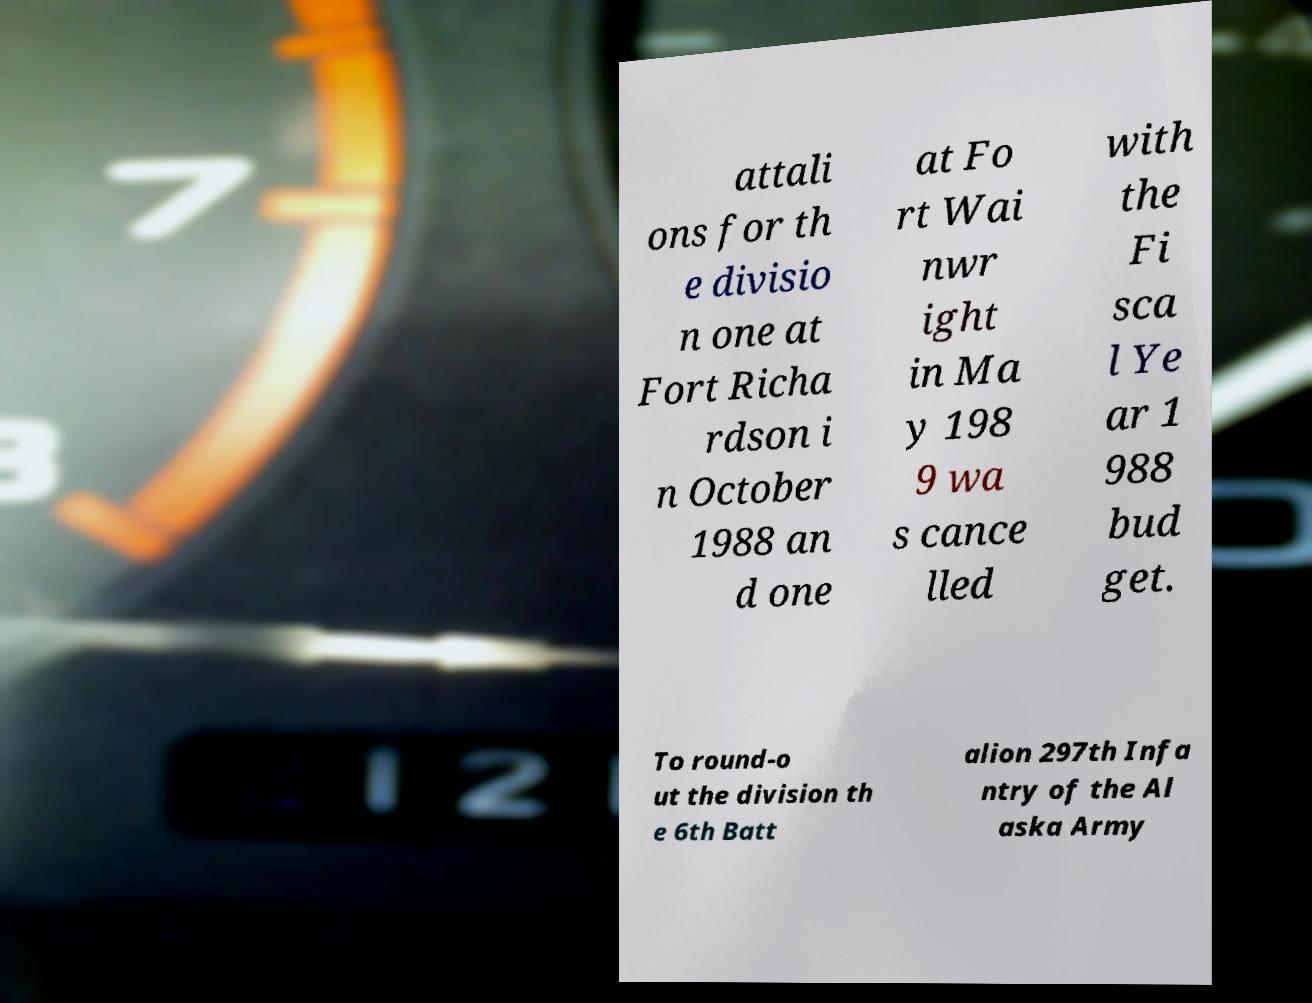Could you extract and type out the text from this image? attali ons for th e divisio n one at Fort Richa rdson i n October 1988 an d one at Fo rt Wai nwr ight in Ma y 198 9 wa s cance lled with the Fi sca l Ye ar 1 988 bud get. To round-o ut the division th e 6th Batt alion 297th Infa ntry of the Al aska Army 